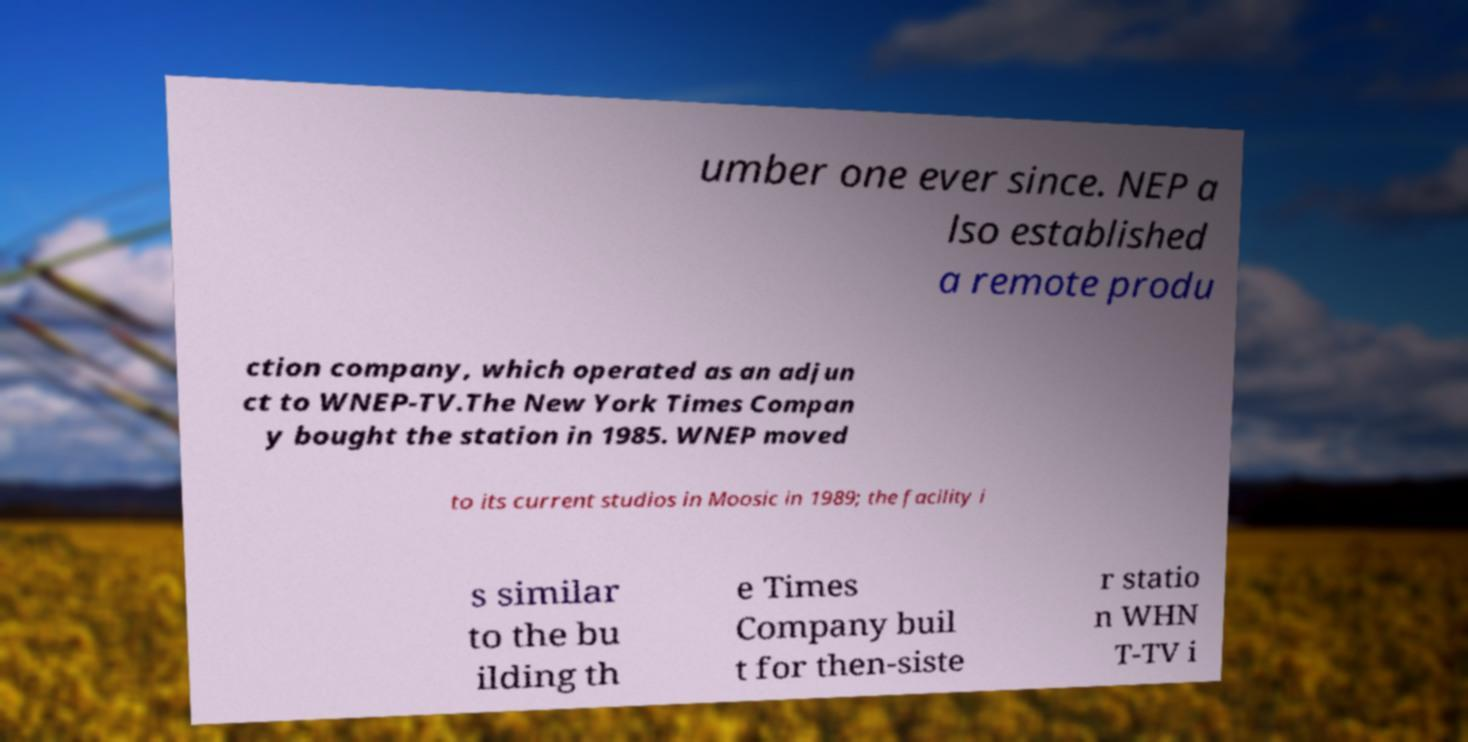Can you accurately transcribe the text from the provided image for me? umber one ever since. NEP a lso established a remote produ ction company, which operated as an adjun ct to WNEP-TV.The New York Times Compan y bought the station in 1985. WNEP moved to its current studios in Moosic in 1989; the facility i s similar to the bu ilding th e Times Company buil t for then-siste r statio n WHN T-TV i 